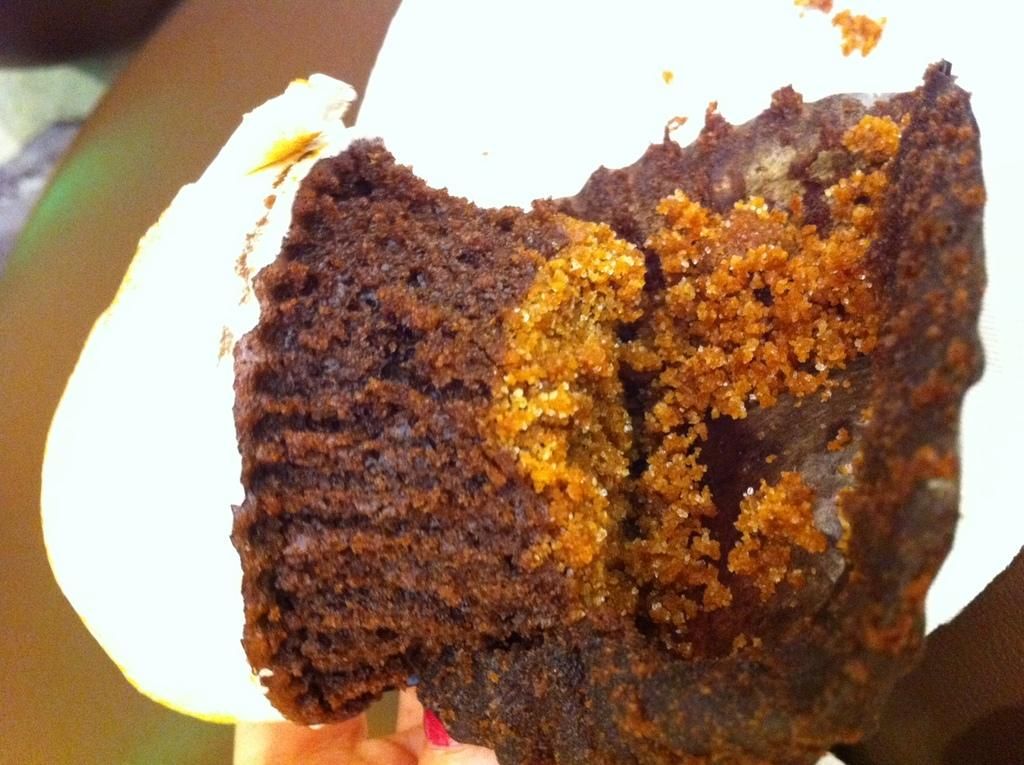What type of picture is the image? The image is a closeup picture. What is the main subject of the image? The subject of the image is a food item. What type of jar is visible in the image? There is no jar present in the image. What activity is taking place in the image? The image is a still picture, so no activity is taking place. 